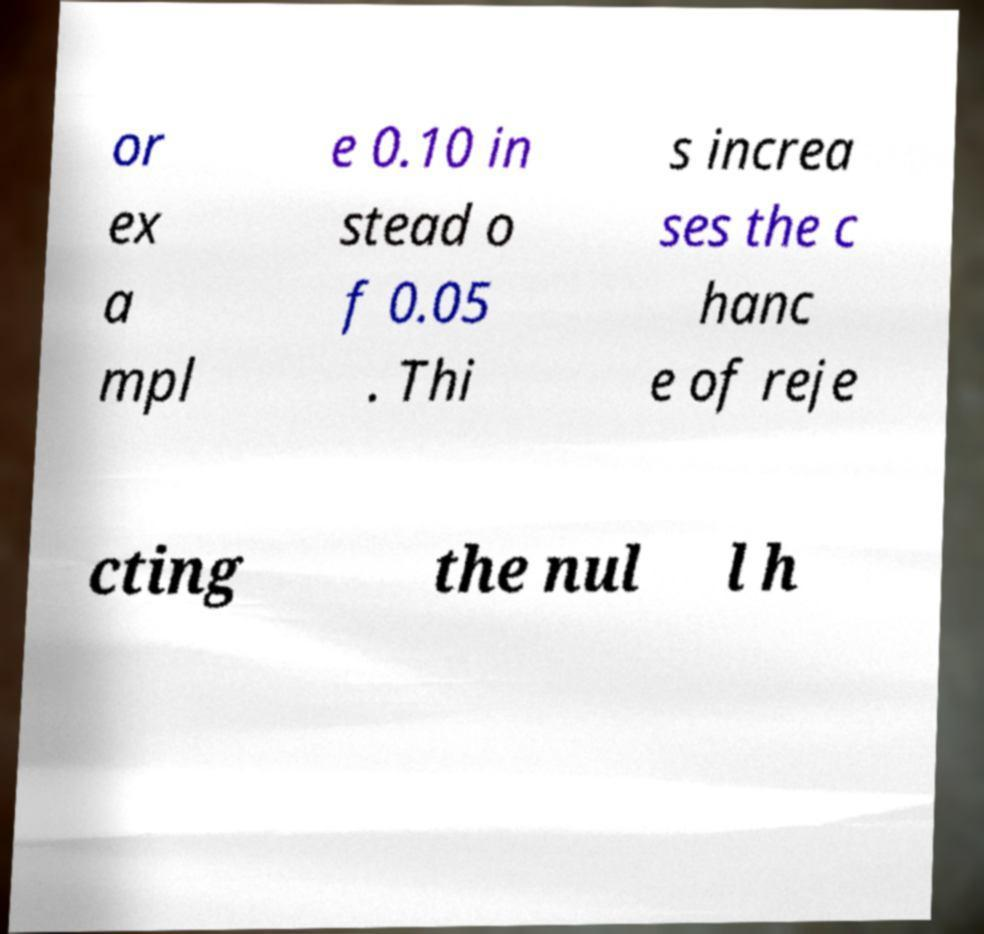Can you read and provide the text displayed in the image?This photo seems to have some interesting text. Can you extract and type it out for me? or ex a mpl e 0.10 in stead o f 0.05 . Thi s increa ses the c hanc e of reje cting the nul l h 